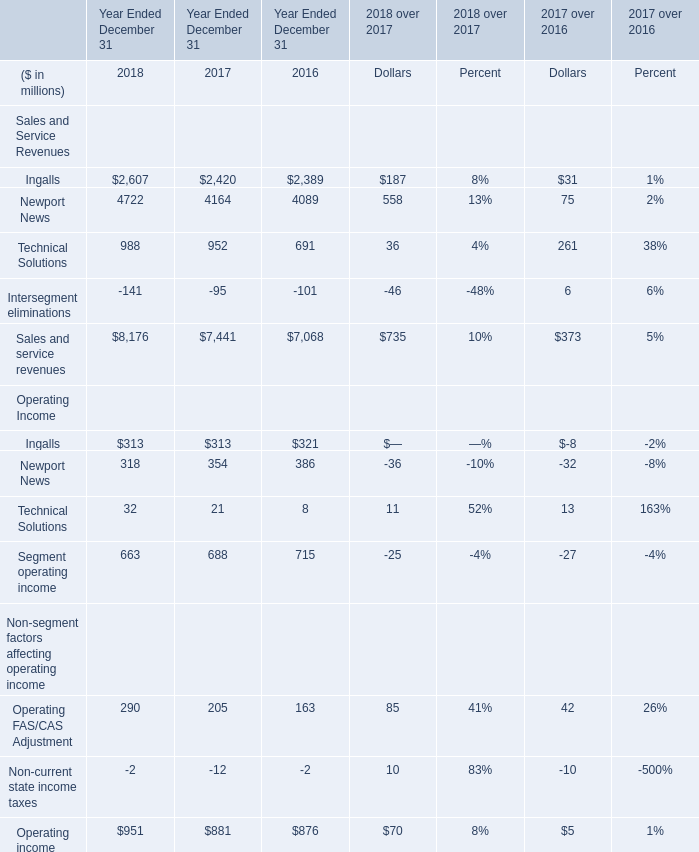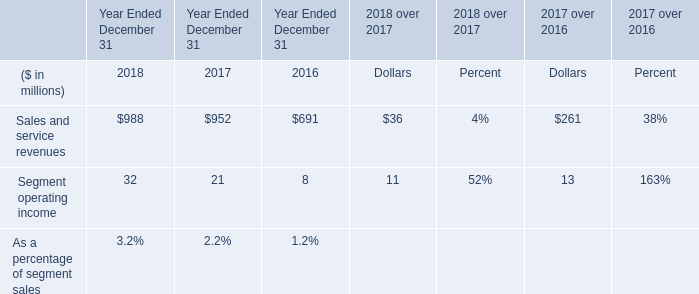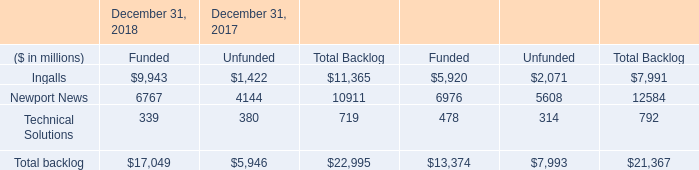what was the percentage increase in the operating income from 2016 to 2017 
Computations: ((21 - 8) / 8)
Answer: 1.625. 